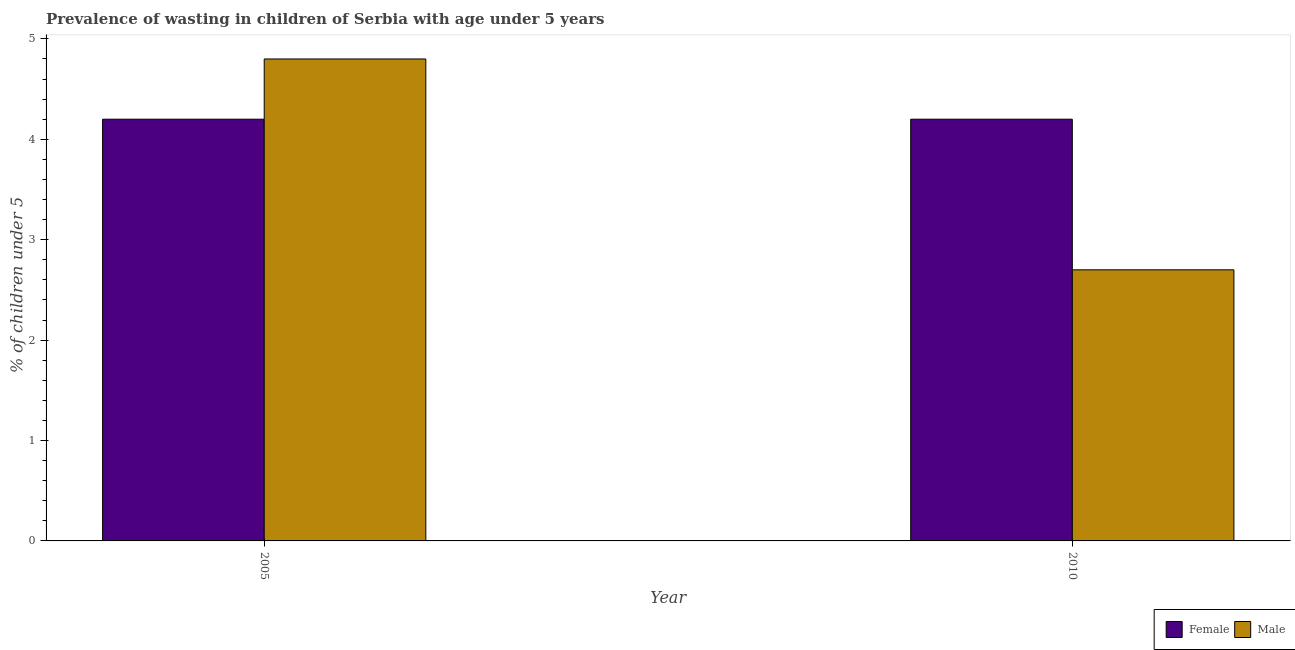How many different coloured bars are there?
Offer a terse response. 2. How many groups of bars are there?
Ensure brevity in your answer.  2. Are the number of bars on each tick of the X-axis equal?
Offer a terse response. Yes. How many bars are there on the 1st tick from the left?
Offer a very short reply. 2. What is the label of the 1st group of bars from the left?
Make the answer very short. 2005. In how many cases, is the number of bars for a given year not equal to the number of legend labels?
Your answer should be very brief. 0. What is the percentage of undernourished female children in 2005?
Keep it short and to the point. 4.2. Across all years, what is the maximum percentage of undernourished female children?
Ensure brevity in your answer.  4.2. Across all years, what is the minimum percentage of undernourished male children?
Ensure brevity in your answer.  2.7. In which year was the percentage of undernourished female children maximum?
Your answer should be compact. 2005. What is the total percentage of undernourished male children in the graph?
Ensure brevity in your answer.  7.5. What is the average percentage of undernourished male children per year?
Your answer should be compact. 3.75. In the year 2005, what is the difference between the percentage of undernourished male children and percentage of undernourished female children?
Your answer should be compact. 0. In how many years, is the percentage of undernourished female children greater than 3.2 %?
Keep it short and to the point. 2. What is the ratio of the percentage of undernourished male children in 2005 to that in 2010?
Provide a succinct answer. 1.78. Are all the bars in the graph horizontal?
Offer a very short reply. No. Are the values on the major ticks of Y-axis written in scientific E-notation?
Your answer should be very brief. No. Does the graph contain any zero values?
Your answer should be compact. No. Does the graph contain grids?
Give a very brief answer. No. Where does the legend appear in the graph?
Your answer should be compact. Bottom right. What is the title of the graph?
Keep it short and to the point. Prevalence of wasting in children of Serbia with age under 5 years. Does "National Tourists" appear as one of the legend labels in the graph?
Make the answer very short. No. What is the label or title of the Y-axis?
Offer a very short reply.  % of children under 5. What is the  % of children under 5 in Female in 2005?
Offer a very short reply. 4.2. What is the  % of children under 5 of Male in 2005?
Keep it short and to the point. 4.8. What is the  % of children under 5 of Female in 2010?
Offer a terse response. 4.2. What is the  % of children under 5 of Male in 2010?
Provide a succinct answer. 2.7. Across all years, what is the maximum  % of children under 5 in Female?
Offer a very short reply. 4.2. Across all years, what is the maximum  % of children under 5 of Male?
Your answer should be very brief. 4.8. Across all years, what is the minimum  % of children under 5 of Female?
Keep it short and to the point. 4.2. Across all years, what is the minimum  % of children under 5 of Male?
Offer a very short reply. 2.7. What is the difference between the  % of children under 5 of Female in 2005 and that in 2010?
Your response must be concise. 0. What is the difference between the  % of children under 5 of Male in 2005 and that in 2010?
Provide a short and direct response. 2.1. What is the difference between the  % of children under 5 in Female in 2005 and the  % of children under 5 in Male in 2010?
Offer a very short reply. 1.5. What is the average  % of children under 5 of Male per year?
Make the answer very short. 3.75. What is the ratio of the  % of children under 5 in Male in 2005 to that in 2010?
Keep it short and to the point. 1.78. What is the difference between the highest and the second highest  % of children under 5 of Male?
Give a very brief answer. 2.1. What is the difference between the highest and the lowest  % of children under 5 of Female?
Give a very brief answer. 0. What is the difference between the highest and the lowest  % of children under 5 in Male?
Offer a very short reply. 2.1. 